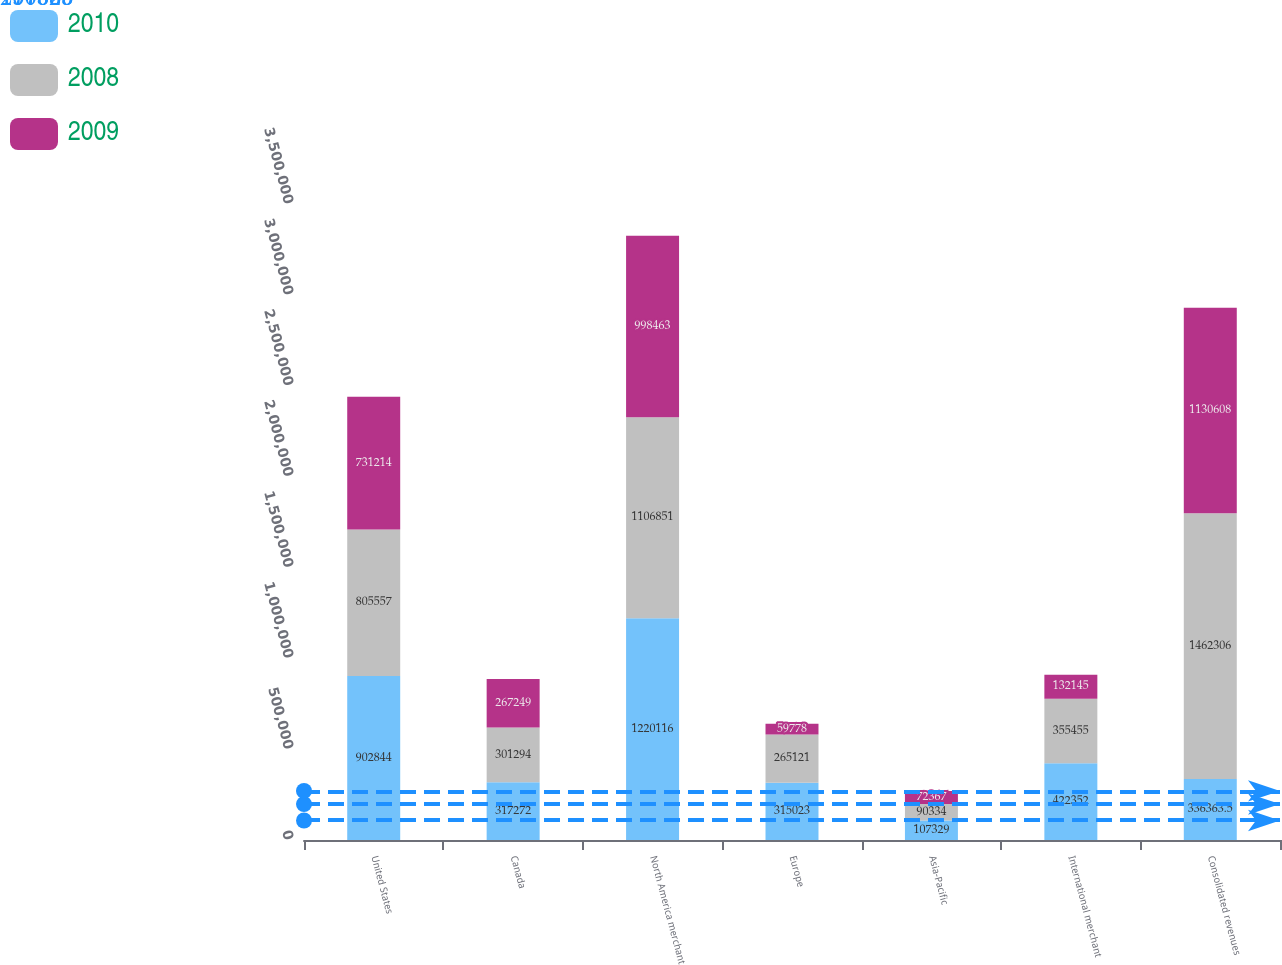Convert chart to OTSL. <chart><loc_0><loc_0><loc_500><loc_500><stacked_bar_chart><ecel><fcel>United States<fcel>Canada<fcel>North America merchant<fcel>Europe<fcel>Asia-Pacific<fcel>International merchant<fcel>Consolidated revenues<nl><fcel>2010<fcel>902844<fcel>317272<fcel>1.22012e+06<fcel>315023<fcel>107329<fcel>422352<fcel>336364<nl><fcel>2008<fcel>805557<fcel>301294<fcel>1.10685e+06<fcel>265121<fcel>90334<fcel>355455<fcel>1.46231e+06<nl><fcel>2009<fcel>731214<fcel>267249<fcel>998463<fcel>59778<fcel>72367<fcel>132145<fcel>1.13061e+06<nl></chart> 